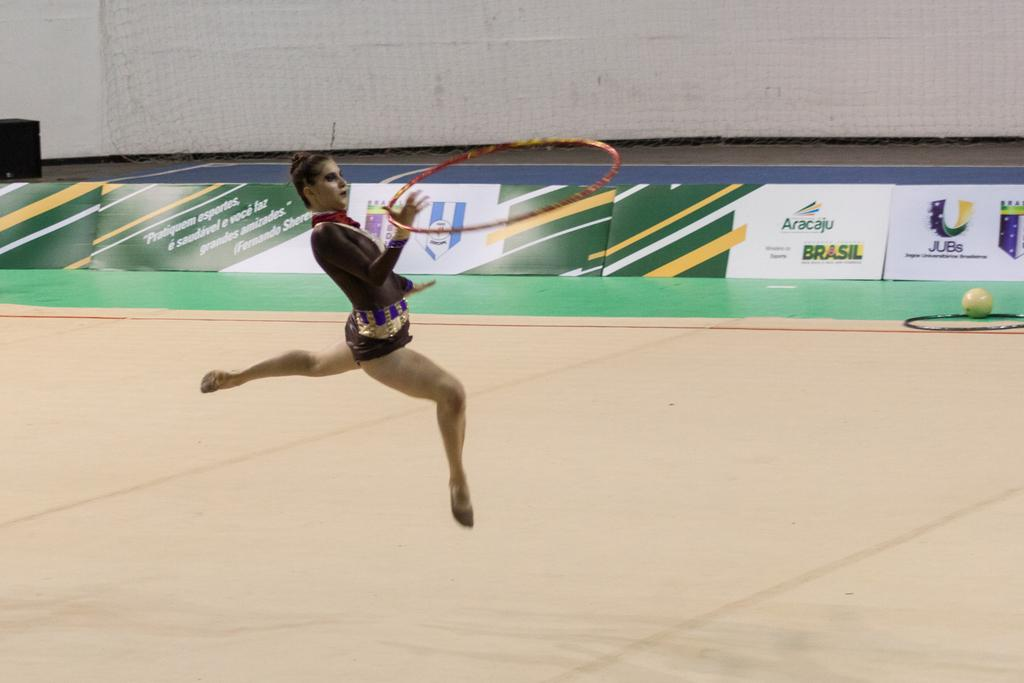<image>
Describe the image concisely. A woman does a dance routine in front of a sign with the word BRASIL on it. 